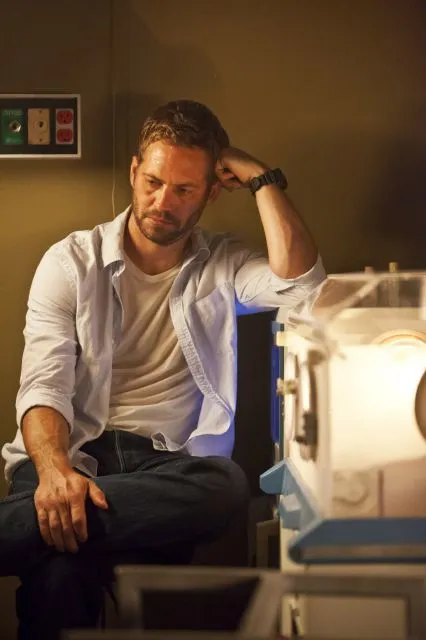How might a short film or story start based on this image? The short film could start with the man sitting in a dimly lit laboratory, the camera panning over various scientific instruments and the soft hum of machines fills the background. The man is seated on the desk, looking intensely thoughtful, as the narrator introduces his background and the critical project he's working on. The opening scene focuses on the man's conflicted expressions as he ponders a significant decision, setting up the premise for a story filled with scientific intrigue and moral dilemmas. 